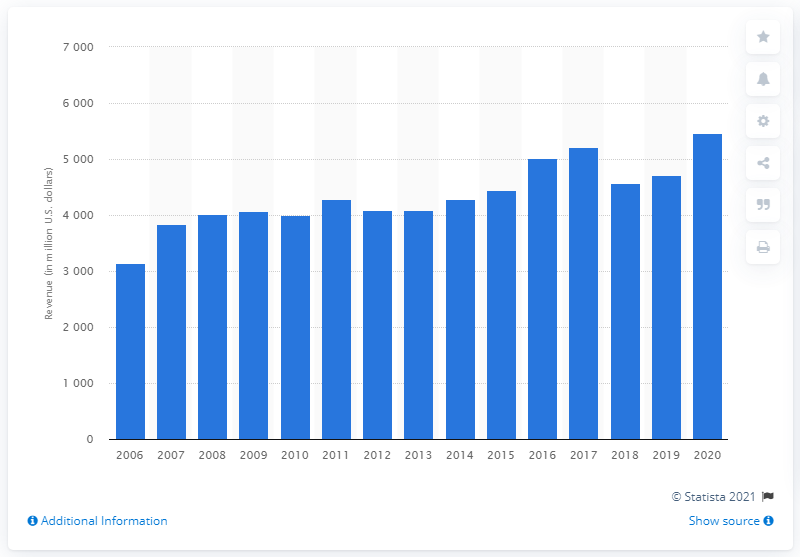Point out several critical features in this image. In 2020, Hasbro's net revenue was $54,654. 